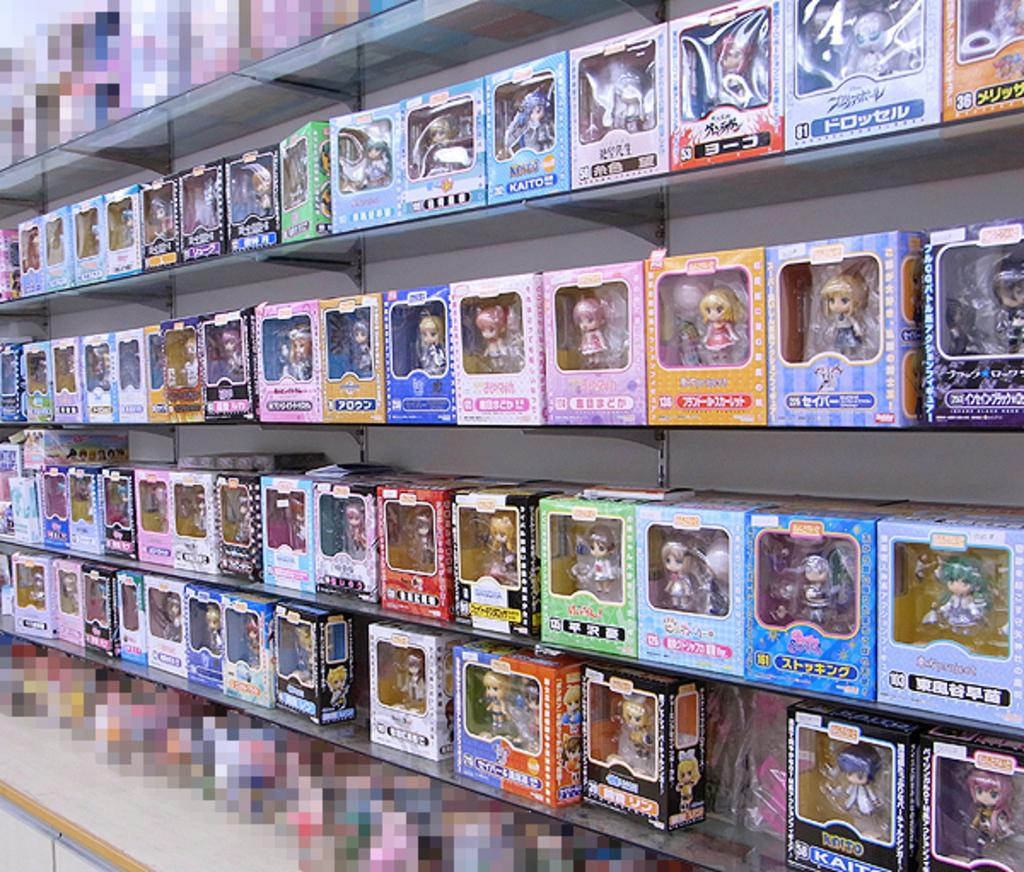<image>
Offer a succinct explanation of the picture presented. A bunch of toys are on display, including one in the top right that says 81. 